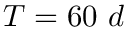<formula> <loc_0><loc_0><loc_500><loc_500>T = 6 0 \ d</formula> 